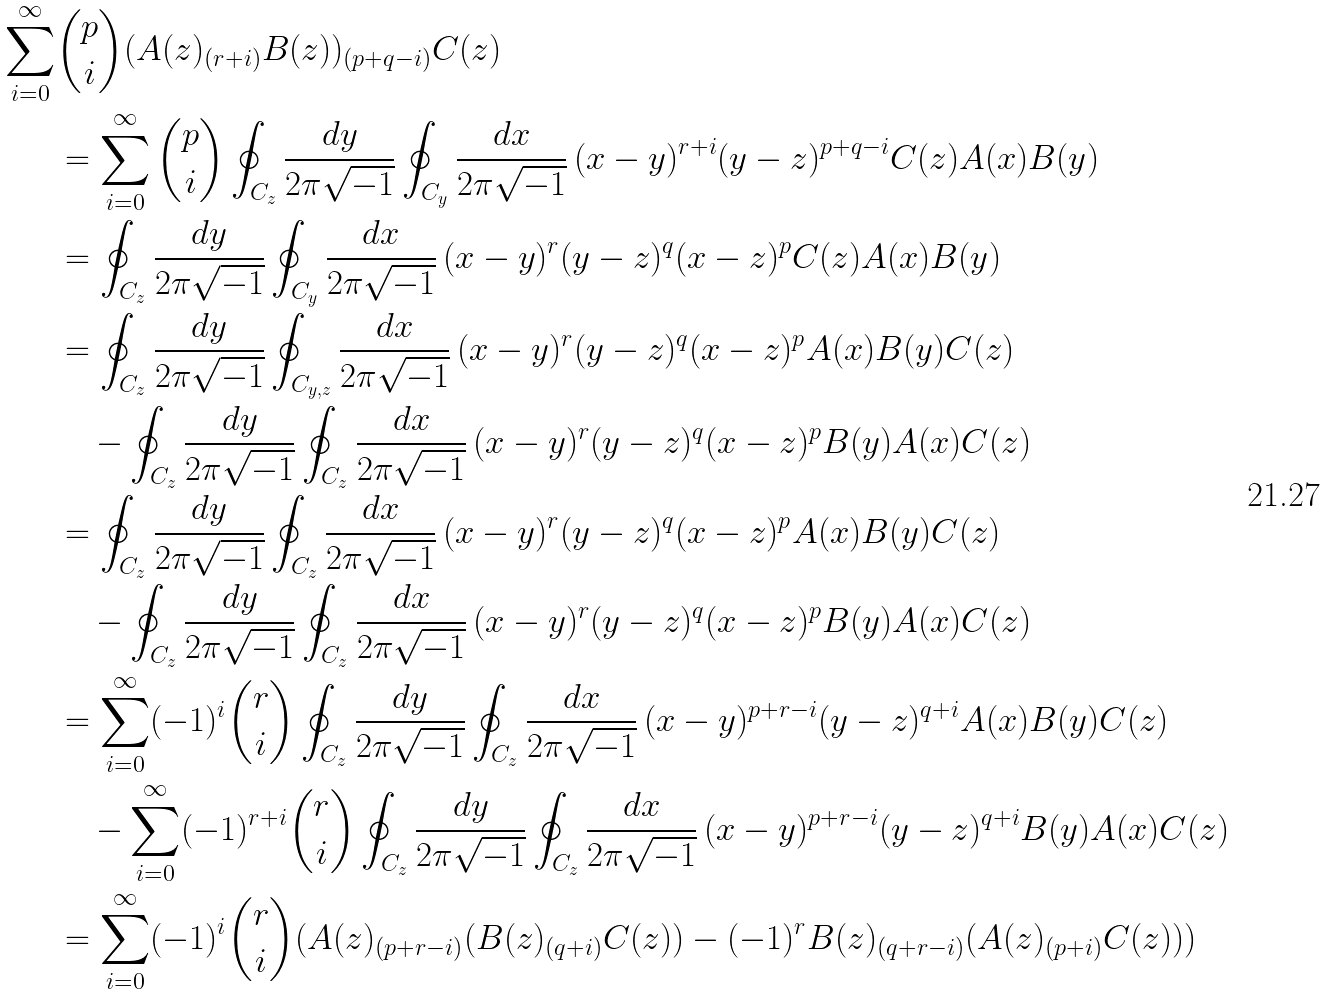Convert formula to latex. <formula><loc_0><loc_0><loc_500><loc_500>\sum _ { i = 0 } ^ { \infty } & \binom { p } { i } ( A ( z ) _ { ( r + i ) } B ( z ) ) _ { ( p + q - i ) } C ( z ) \\ & = \sum _ { i = 0 } ^ { \infty } \binom { p } { i } \oint _ { C _ { z } } \frac { d y } { 2 \pi \sqrt { - 1 } } \oint _ { C _ { y } } \frac { d x } { 2 \pi \sqrt { - 1 } } \, ( x - y ) ^ { r + i } ( y - z ) ^ { p + q - i } C ( z ) A ( x ) B ( y ) \\ & = \oint _ { C _ { z } } \frac { d y } { 2 \pi \sqrt { - 1 } } \oint _ { C _ { y } } \frac { d x } { 2 \pi \sqrt { - 1 } } \, ( x - y ) ^ { r } ( y - z ) ^ { q } ( x - z ) ^ { p } C ( z ) A ( x ) B ( y ) \\ & = \oint _ { C _ { z } } \frac { d y } { 2 \pi \sqrt { - 1 } } \oint _ { C _ { y , z } } \frac { d x } { 2 \pi \sqrt { - 1 } } \, ( x - y ) ^ { r } ( y - z ) ^ { q } ( x - z ) ^ { p } A ( x ) B ( y ) C ( z ) \\ & \quad - \oint _ { C _ { z } } \frac { d y } { 2 \pi \sqrt { - 1 } } \oint _ { C _ { z } } \frac { d x } { 2 \pi \sqrt { - 1 } } \, ( x - y ) ^ { r } ( y - z ) ^ { q } ( x - z ) ^ { p } B ( y ) A ( x ) C ( z ) \\ & = \oint _ { C _ { z } } \frac { d y } { 2 \pi \sqrt { - 1 } } \oint _ { C _ { z } } \frac { d x } { 2 \pi \sqrt { - 1 } } \, ( x - y ) ^ { r } ( y - z ) ^ { q } ( x - z ) ^ { p } A ( x ) B ( y ) C ( z ) \\ & \quad - \oint _ { C _ { z } } \frac { d y } { 2 \pi \sqrt { - 1 } } \oint _ { C _ { z } } \frac { d x } { 2 \pi \sqrt { - 1 } } \, ( x - y ) ^ { r } ( y - z ) ^ { q } ( x - z ) ^ { p } B ( y ) A ( x ) C ( z ) \\ & = \sum _ { i = 0 } ^ { \infty } ( - 1 ) ^ { i } \binom { r } { i } \oint _ { C _ { z } } \frac { d y } { 2 \pi \sqrt { - 1 } } \oint _ { C _ { z } } \frac { d x } { 2 \pi \sqrt { - 1 } } \, ( x - y ) ^ { p + r - i } ( y - z ) ^ { q + i } A ( x ) B ( y ) C ( z ) \\ & \quad - \sum _ { i = 0 } ^ { \infty } ( - 1 ) ^ { r + i } \binom { r } { i } \oint _ { C _ { z } } \frac { d y } { 2 \pi \sqrt { - 1 } } \oint _ { C _ { z } } \frac { d x } { 2 \pi \sqrt { - 1 } } \, ( x - y ) ^ { p + r - i } ( y - z ) ^ { q + i } B ( y ) A ( x ) C ( z ) \\ & = \sum _ { i = 0 } ^ { \infty } ( - 1 ) ^ { i } \binom { r } { i } ( A ( z ) _ { ( p + r - i ) } ( B ( z ) _ { ( q + i ) } C ( z ) ) - ( - 1 ) ^ { r } B ( z ) _ { ( q + r - i ) } ( A ( z ) _ { ( p + i ) } C ( z ) ) )</formula> 